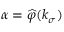<formula> <loc_0><loc_0><loc_500><loc_500>\alpha = \widehat { \varphi } ( k _ { \sigma } )</formula> 